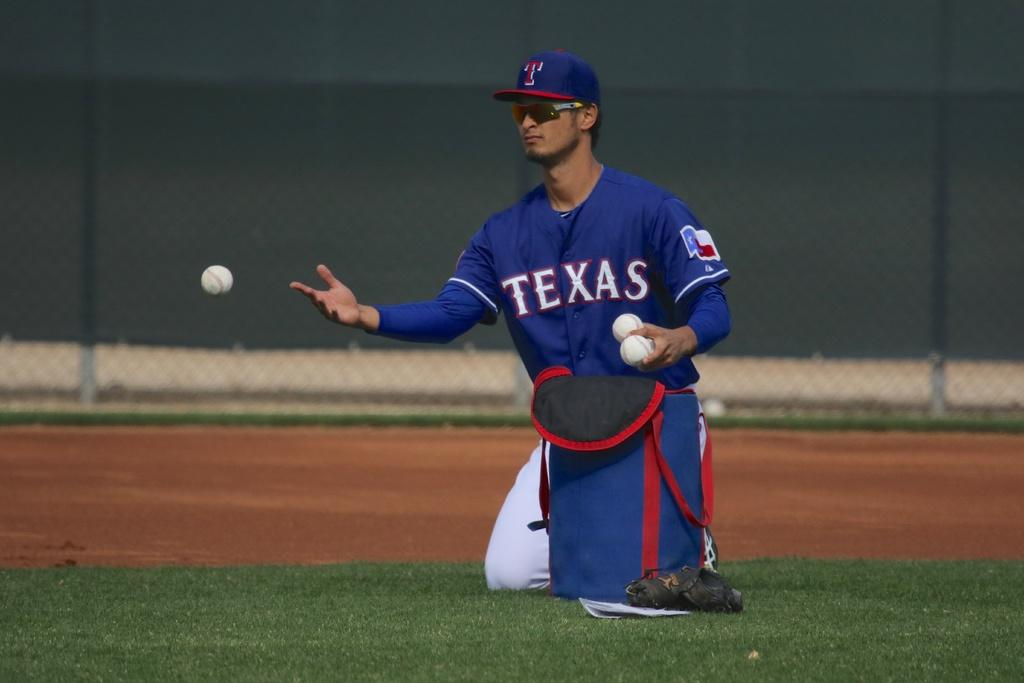Provide a one-sentence caption for the provided image. A man in a Texas baseball uniform is taking ball out of a blue bag on the field. 